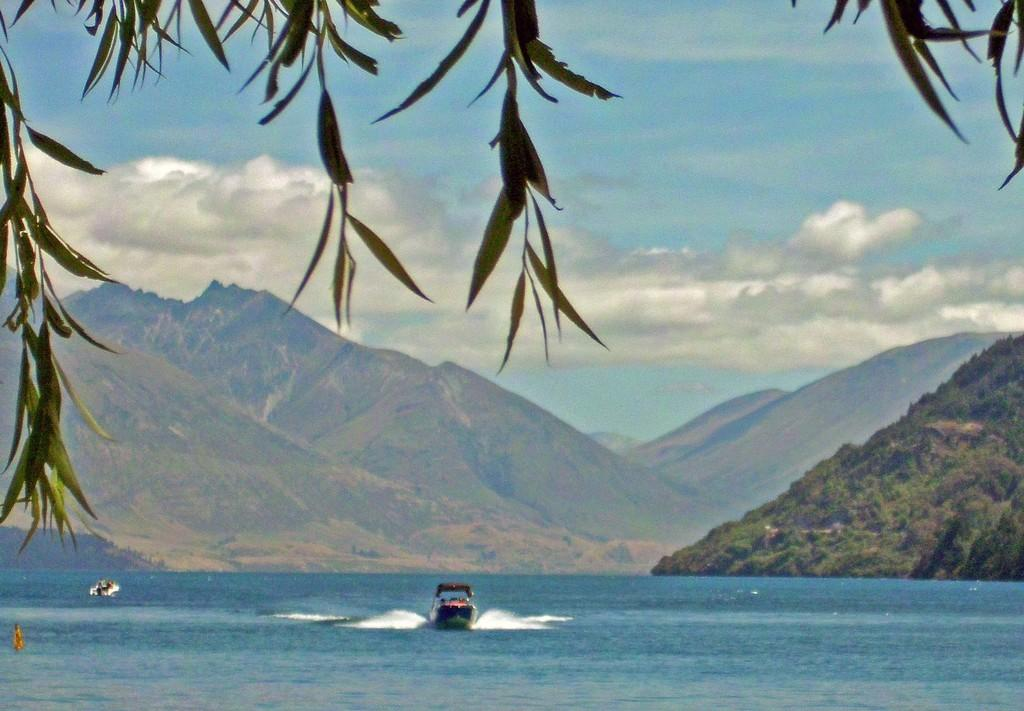What type of vehicles can be seen in the image? There are boats on the water in the image. What type of natural environment is visible in the image? Trees and mountains are present in the image. What is visible in the background of the image? The sky is visible in the background of the image. What can be seen in the sky? Clouds are present in the sky. What type of furniture can be seen in the bedroom in the image? There is no bedroom or furniture present in the image; it features boats on the water, trees, mountains, and the sky. 